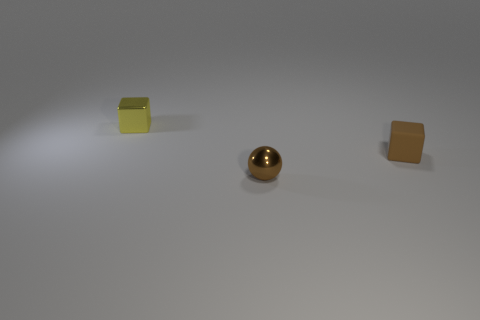What is the material of the object that is both on the left side of the brown rubber cube and right of the yellow block?
Offer a terse response. Metal. How many brown metallic spheres have the same size as the matte thing?
Keep it short and to the point. 1. There is another thing that is the same shape as the matte thing; what is it made of?
Provide a short and direct response. Metal. What number of objects are either small objects left of the rubber object or blocks that are behind the brown rubber object?
Offer a terse response. 2. There is a matte object; is its shape the same as the metal thing on the left side of the sphere?
Ensure brevity in your answer.  Yes. What is the shape of the thing behind the block that is in front of the block on the left side of the tiny rubber object?
Your answer should be very brief. Cube. How many other things are the same material as the small brown cube?
Your answer should be very brief. 0. How many things are either small things that are to the left of the brown rubber object or large blue matte cubes?
Make the answer very short. 2. There is a small object on the right side of the brown ball in front of the small yellow shiny object; what shape is it?
Ensure brevity in your answer.  Cube. Does the metal object that is on the right side of the small yellow metallic cube have the same shape as the tiny brown rubber thing?
Your answer should be very brief. No. 